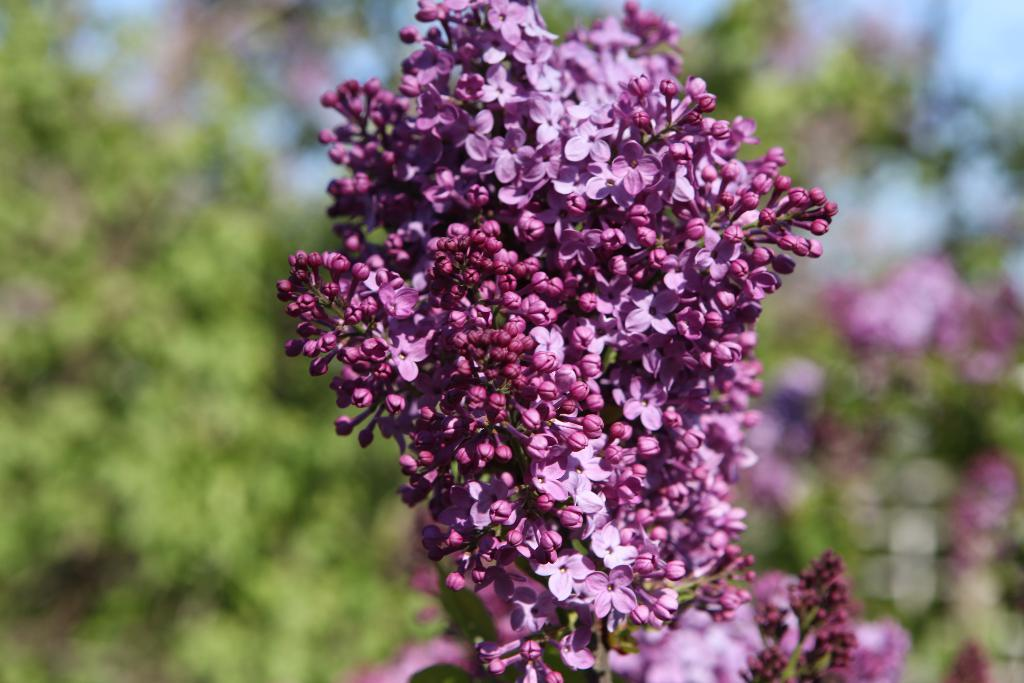What is present in the image? There are flowers in the image. Can you describe the background of the image? The background of the image is blurred. What time does the head start in the image? There is no head or start time present in the image; it only features flowers and a blurred background. 